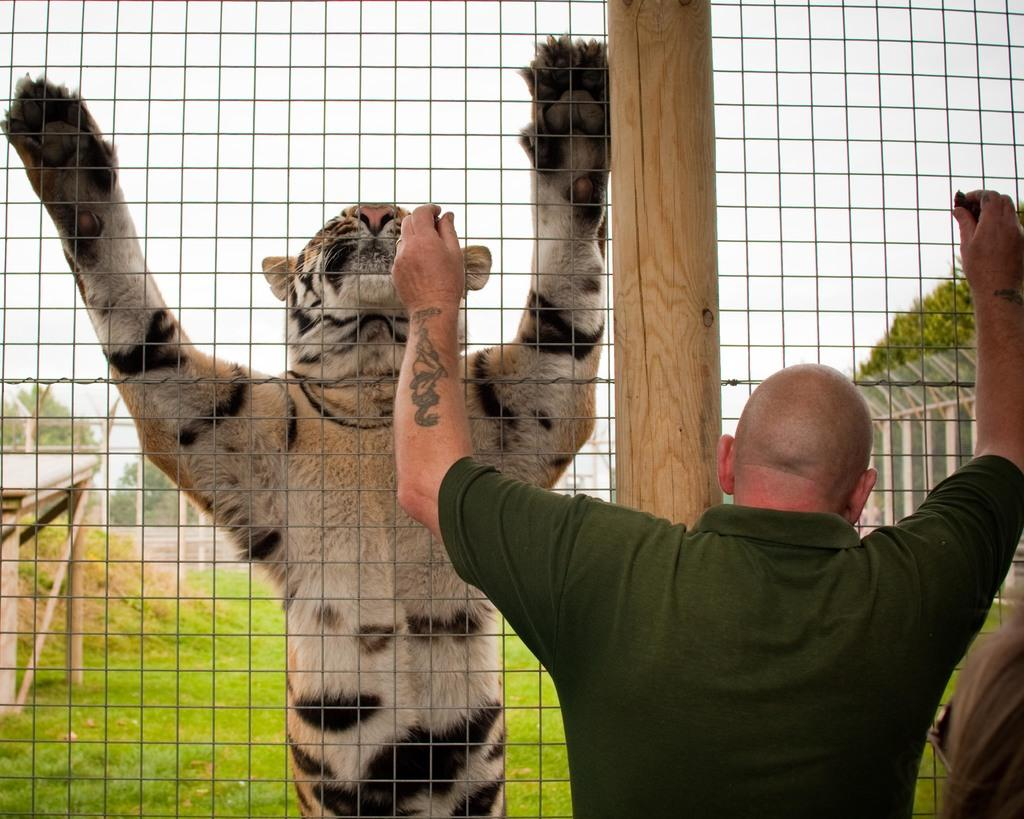Who is present in the image? There is a man in the image. What animal is also present in the image? There is a tiger in the image. What is separating the man and the tiger in the image? There is a mesh in the image. What can be seen in the background of the image? There are trees in the background of the image. What type of vegetation covers the ground in the image? The ground is covered with grass at the bottom of the image. What type of disgust can be seen on the man's face in the image? There is no indication of disgust on the man's face in the image. 